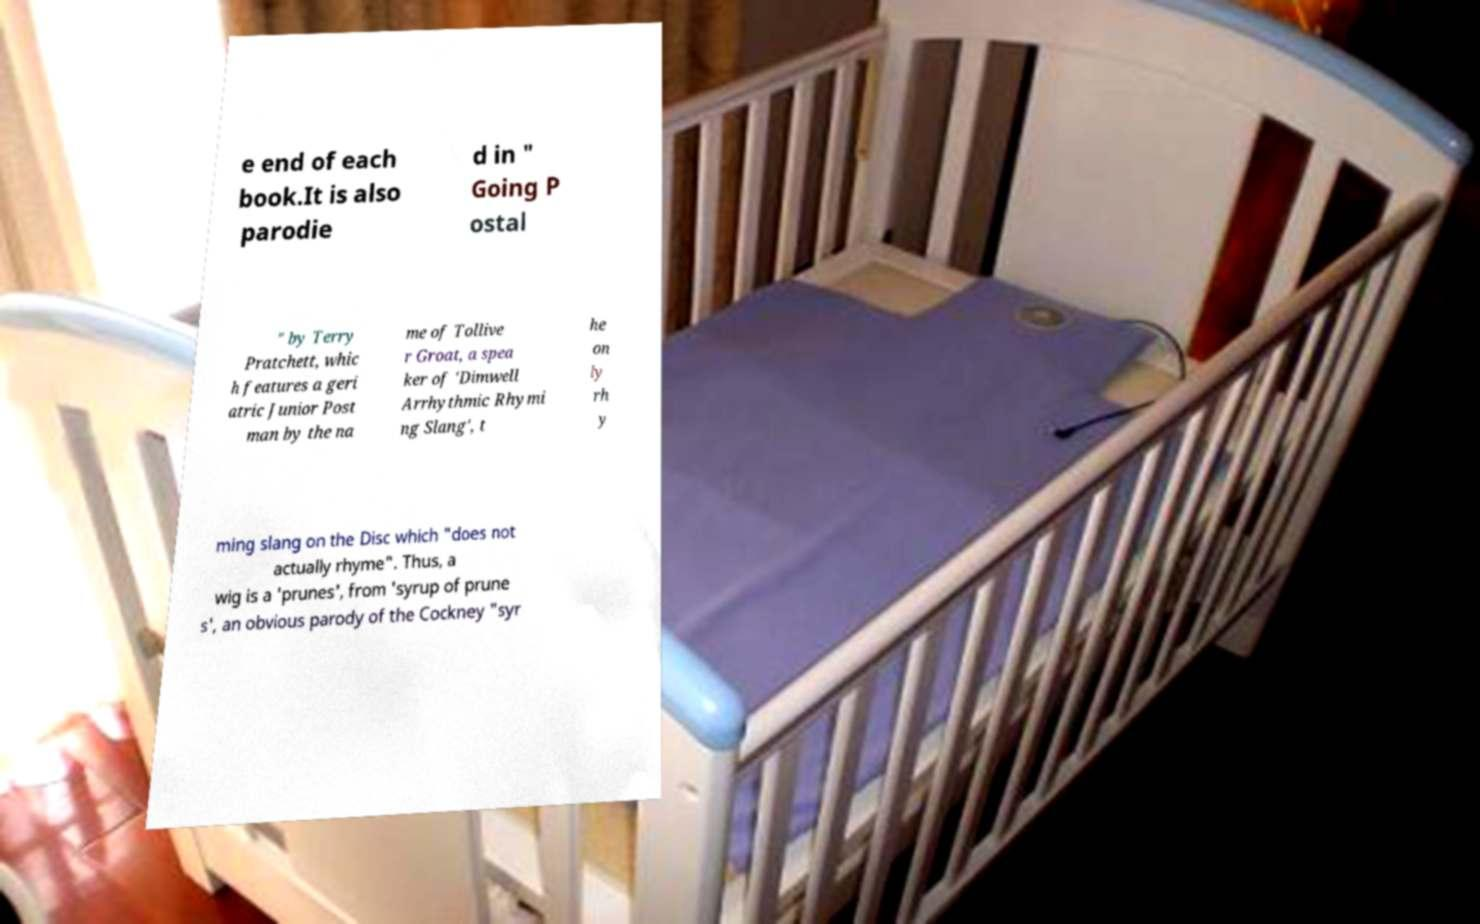There's text embedded in this image that I need extracted. Can you transcribe it verbatim? e end of each book.It is also parodie d in " Going P ostal " by Terry Pratchett, whic h features a geri atric Junior Post man by the na me of Tollive r Groat, a spea ker of 'Dimwell Arrhythmic Rhymi ng Slang', t he on ly rh y ming slang on the Disc which "does not actually rhyme". Thus, a wig is a 'prunes', from 'syrup of prune s', an obvious parody of the Cockney "syr 